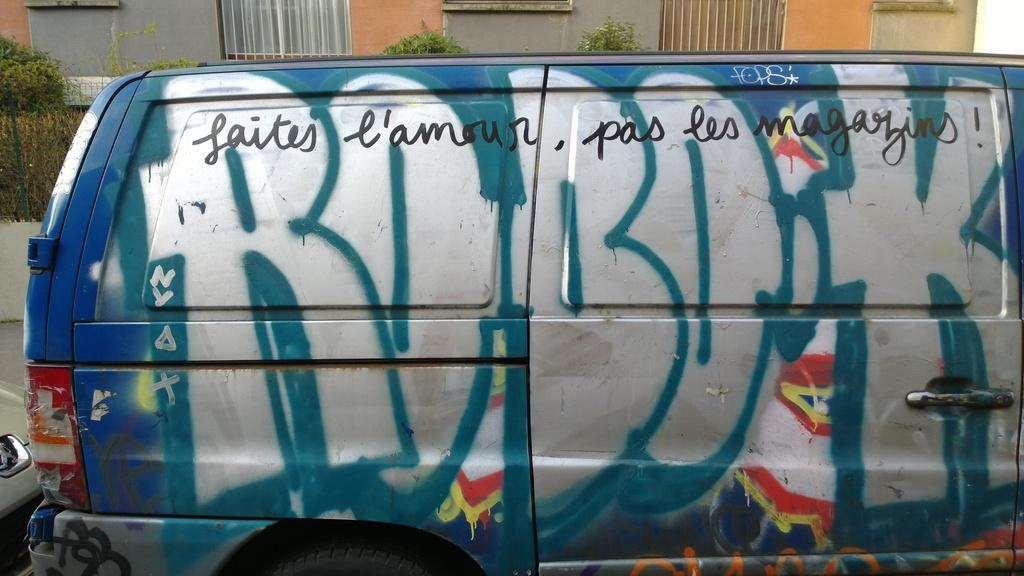<image>
Provide a brief description of the given image. the word laites that is on a van 